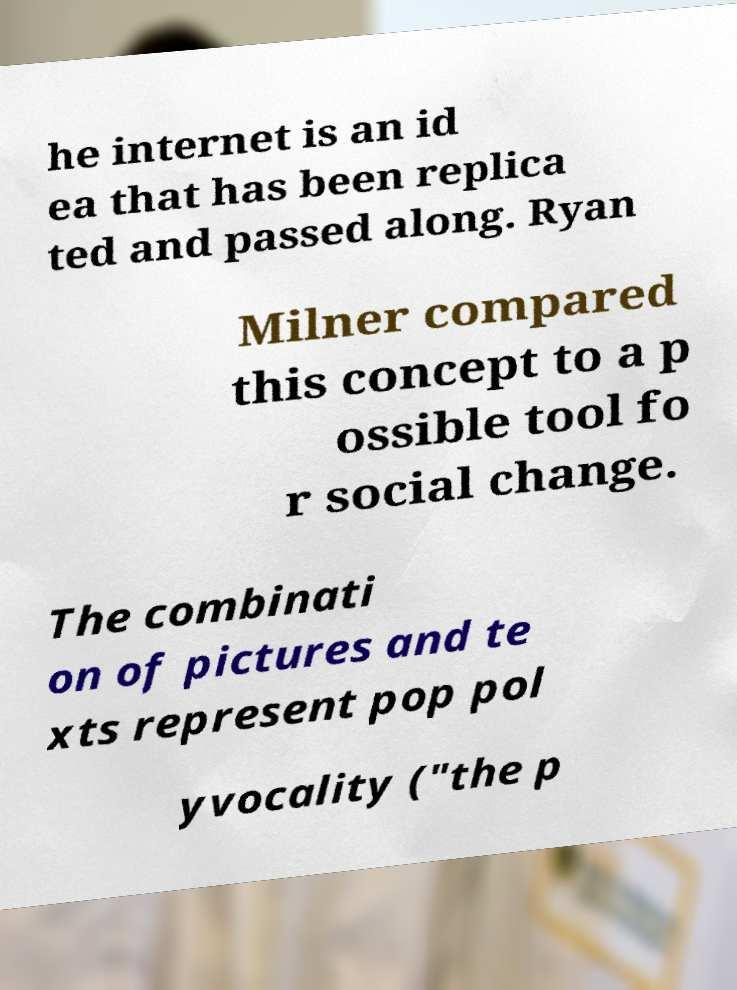I need the written content from this picture converted into text. Can you do that? he internet is an id ea that has been replica ted and passed along. Ryan Milner compared this concept to a p ossible tool fo r social change. The combinati on of pictures and te xts represent pop pol yvocality ("the p 